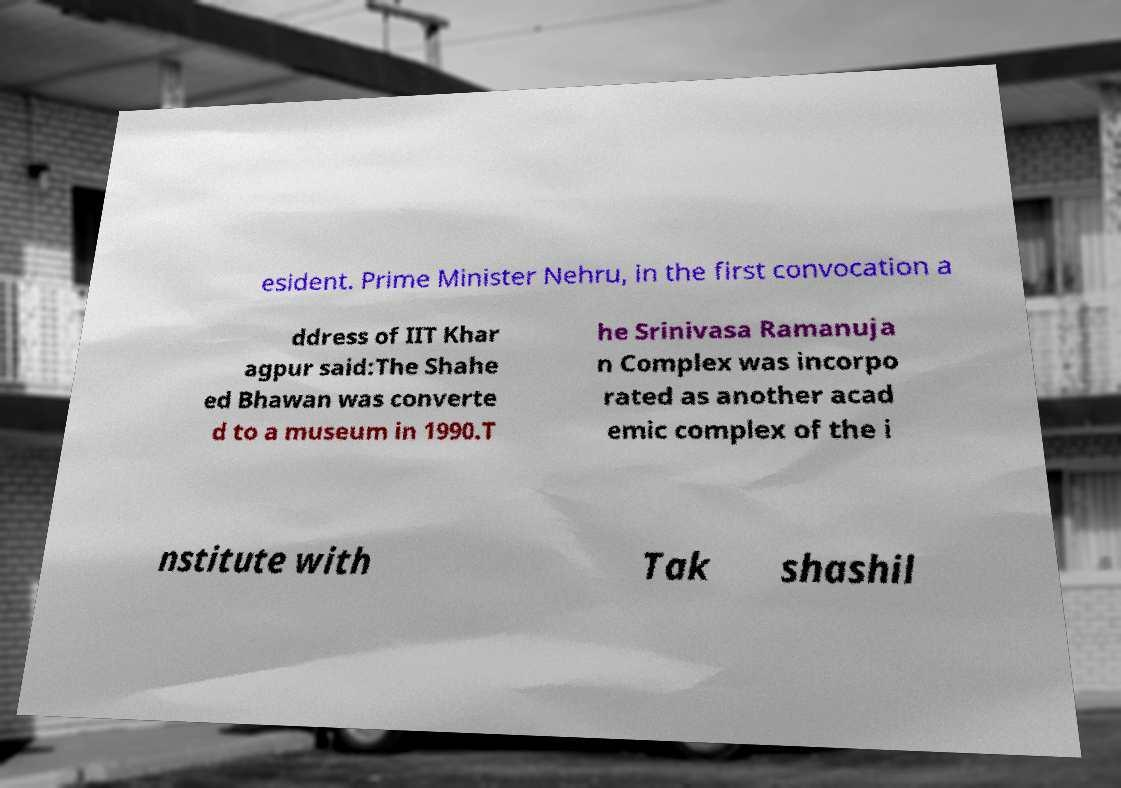Can you accurately transcribe the text from the provided image for me? esident. Prime Minister Nehru, in the first convocation a ddress of IIT Khar agpur said:The Shahe ed Bhawan was converte d to a museum in 1990.T he Srinivasa Ramanuja n Complex was incorpo rated as another acad emic complex of the i nstitute with Tak shashil 